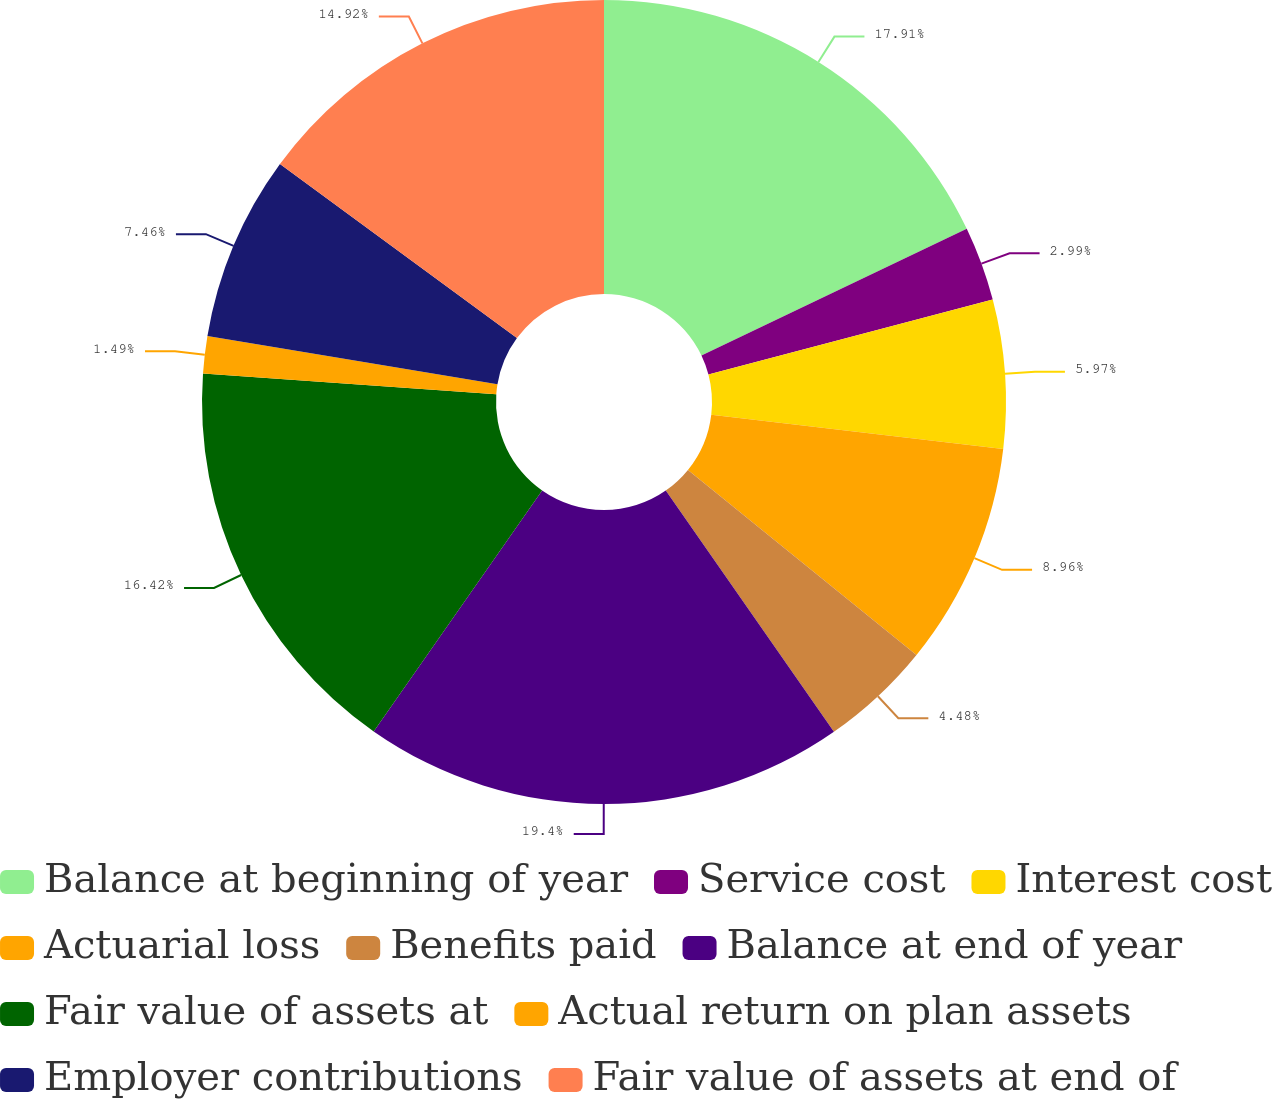<chart> <loc_0><loc_0><loc_500><loc_500><pie_chart><fcel>Balance at beginning of year<fcel>Service cost<fcel>Interest cost<fcel>Actuarial loss<fcel>Benefits paid<fcel>Balance at end of year<fcel>Fair value of assets at<fcel>Actual return on plan assets<fcel>Employer contributions<fcel>Fair value of assets at end of<nl><fcel>17.91%<fcel>2.99%<fcel>5.97%<fcel>8.96%<fcel>4.48%<fcel>19.4%<fcel>16.42%<fcel>1.49%<fcel>7.46%<fcel>14.92%<nl></chart> 